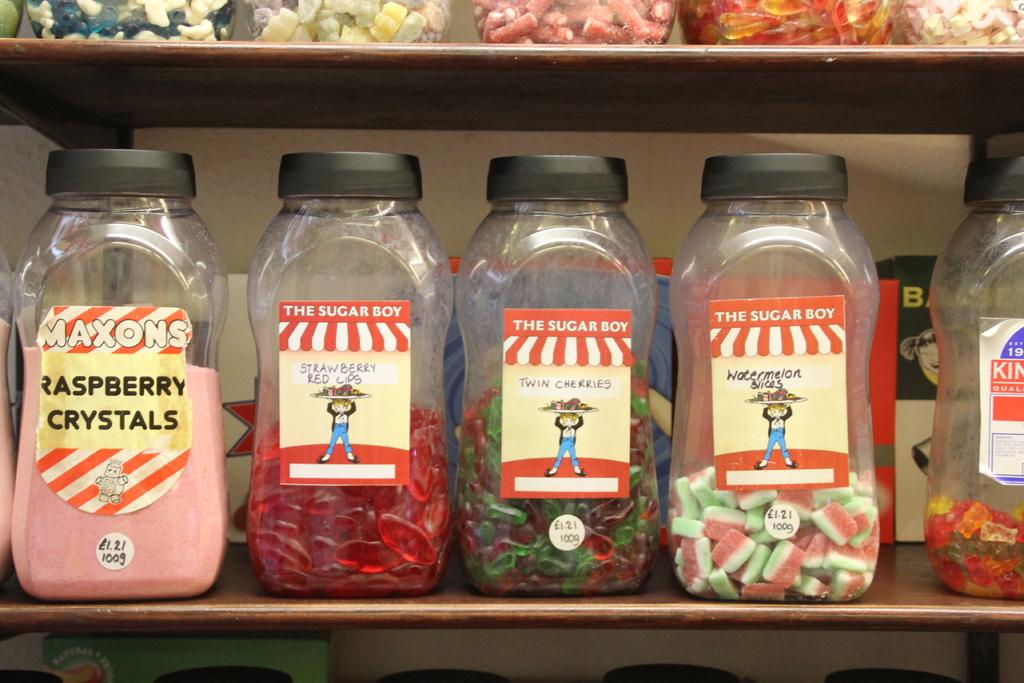What type of furniture is present in the image? There is a table in the image. What objects are placed on the table? There are bottles on the table. What information is provided on the bottles? The bottles are labeled as 'THE SUGAR BOY'. How many breaths can be counted in the image? There is no reference to breaths in the image, so it is not possible to count them. 